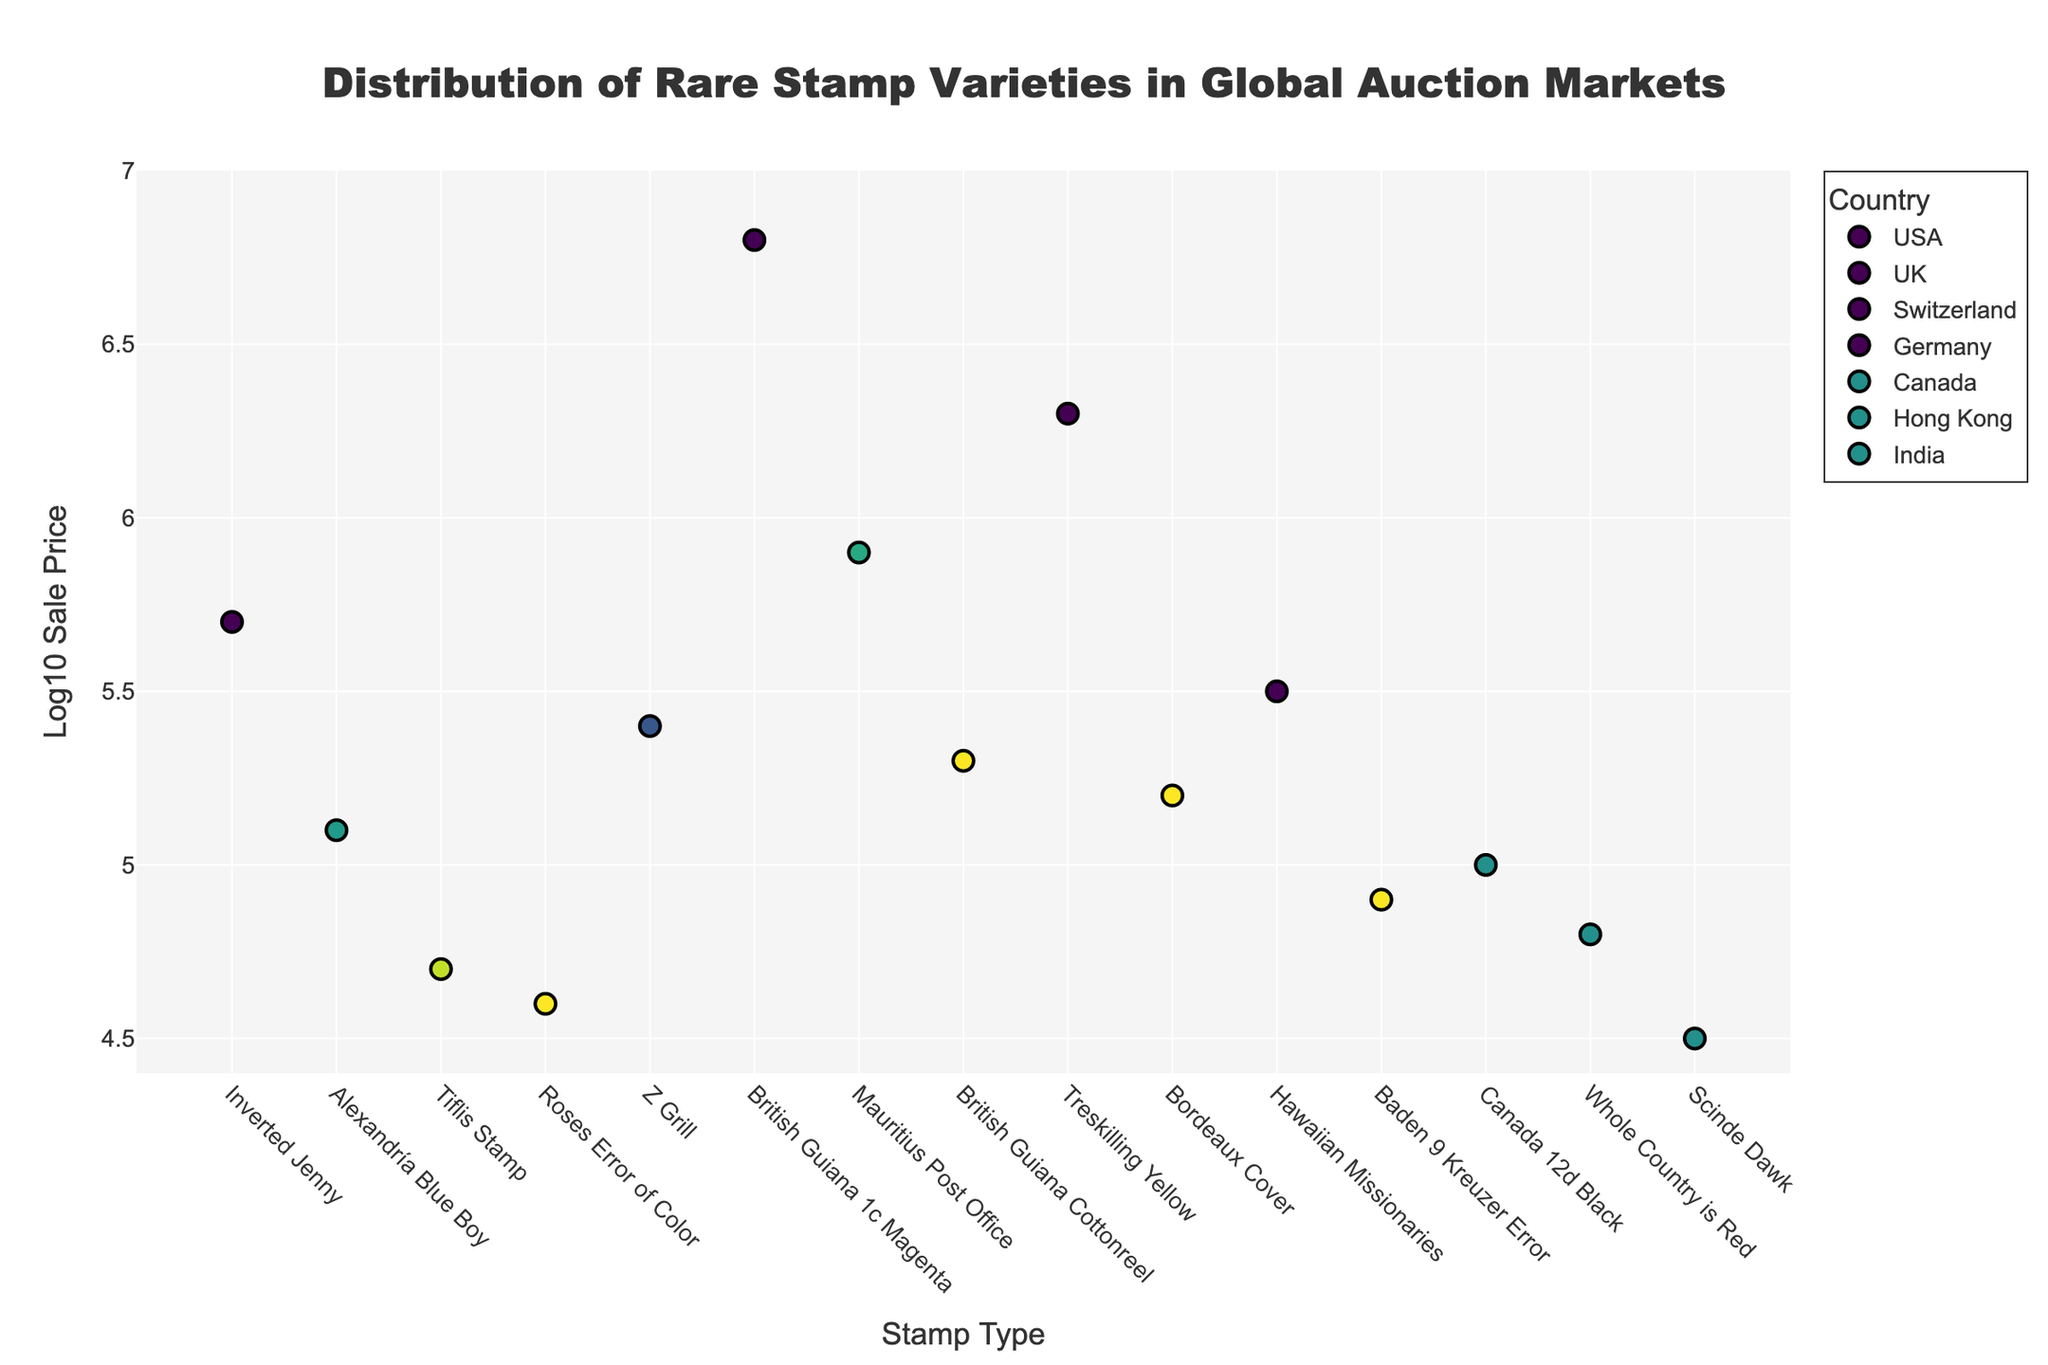How many countries are represented in the figure? The legend lists each country represented in the dataset. By counting the unique entries in the legend, you can determine the number of countries.
Answer: 7 Which stamp type has the highest log10 sale price? The highest point on the y-axis represents the highest log10 sale price. By identifying the corresponding x-axis label for that point, you determine the stamp type.
Answer: British Guiana 1c Magenta Between the Inverted Jenny and the Z Grill, which has the higher log10 sale price? Compare the y-values of the points corresponding to the "Inverted Jenny" and "Z Grill". The higher y-value indicates the higher log10 sale price.
Answer: Inverted Jenny What is the range of log10 sale prices for stamps auctioned in Germany? Identify the points corresponding to Germany and note their y-values. The range is determined by subtracting the smallest y-value from the largest y-value among these points.
Answer: 0.6 Calculate the average log10 sale price of the stamps auctioned in the USA. Identify the points corresponding to the USA and sum their y-values. Divide this sum by the number of points to find the average log10 sale price.
Answer: 5 Which auction house sold the stamp with the lowest log10 sale price in the plot? Identify the point with the lowest y-value and refer to the hover text for the auction house name associated with this point.
Answer: Spink 